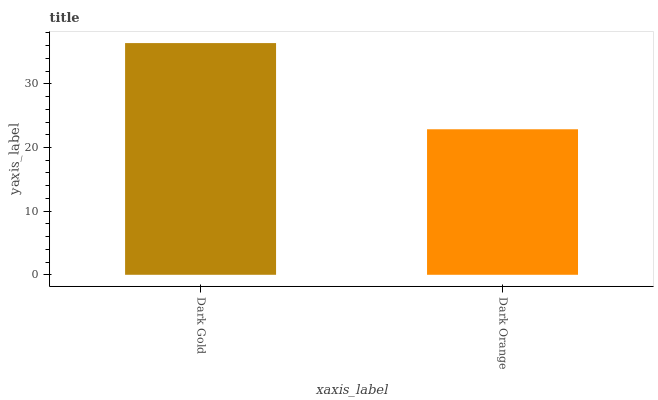Is Dark Orange the minimum?
Answer yes or no. Yes. Is Dark Gold the maximum?
Answer yes or no. Yes. Is Dark Orange the maximum?
Answer yes or no. No. Is Dark Gold greater than Dark Orange?
Answer yes or no. Yes. Is Dark Orange less than Dark Gold?
Answer yes or no. Yes. Is Dark Orange greater than Dark Gold?
Answer yes or no. No. Is Dark Gold less than Dark Orange?
Answer yes or no. No. Is Dark Gold the high median?
Answer yes or no. Yes. Is Dark Orange the low median?
Answer yes or no. Yes. Is Dark Orange the high median?
Answer yes or no. No. Is Dark Gold the low median?
Answer yes or no. No. 